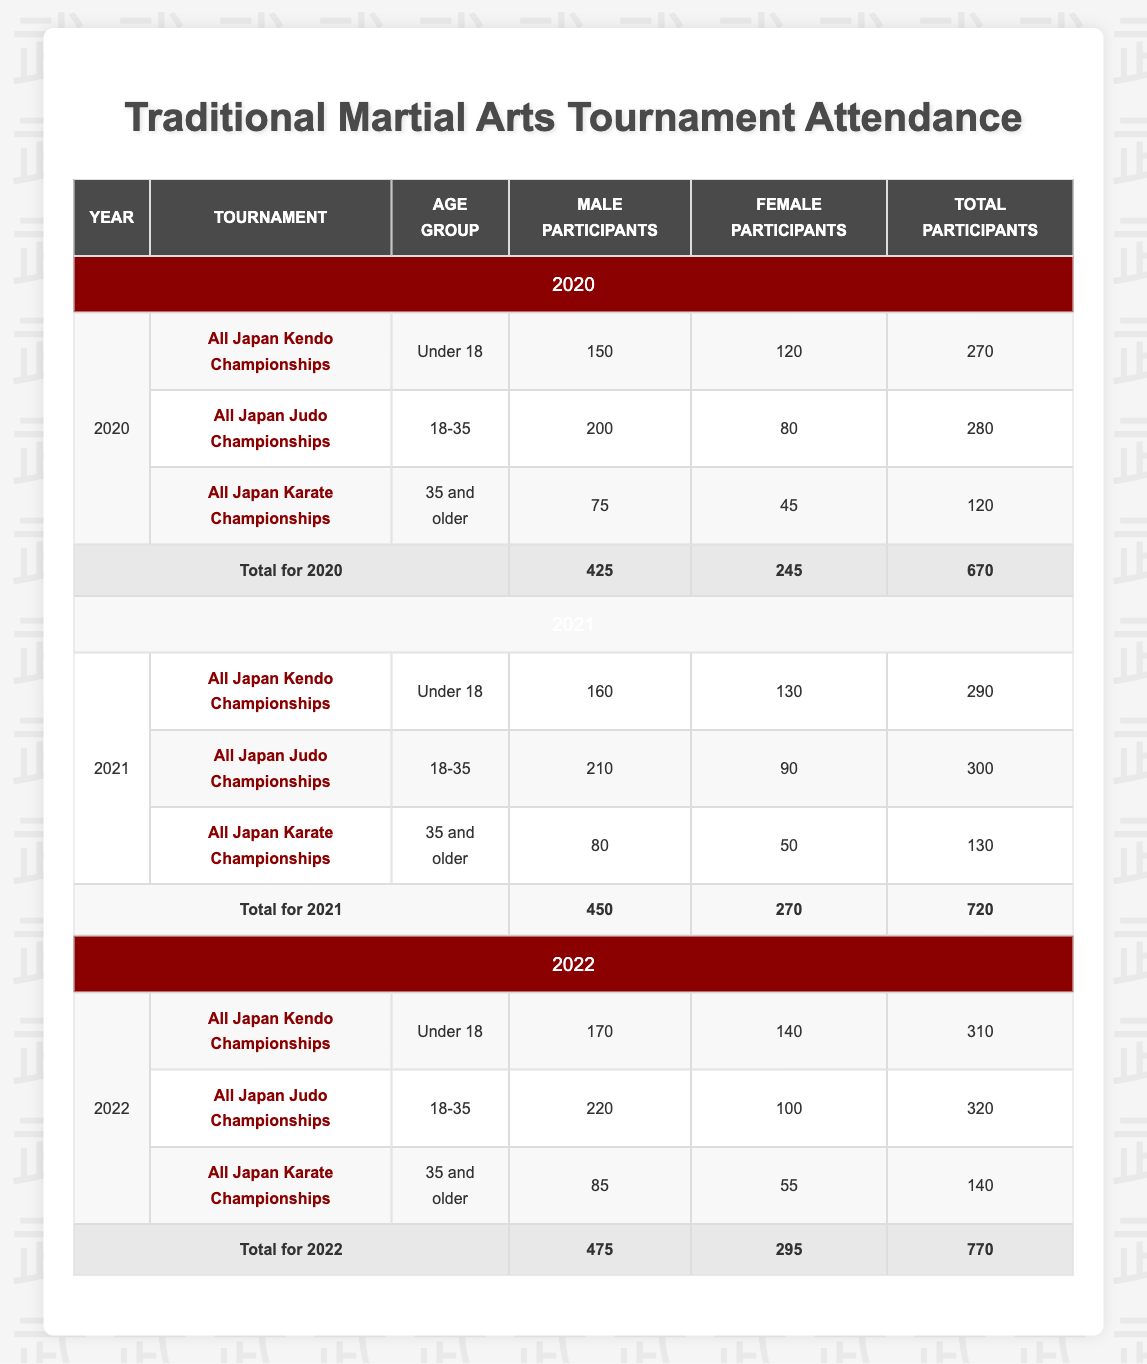What was the total number of male participants in the All Japan Judo Championships in 2021? To find the total, I look at the All Japan Judo Championships row for 2021, which shows there were 210 male participants in the age group 18-35.
Answer: 210 Which tournament had the highest number of female participants in 2022? In the year 2022, comparing the female participants across all tournaments: All Japan Kendo Championships had 140, All Japan Judo Championships had 100, and All Japan Karate Championships had 55. The highest number is 140 in the All Japan Kendo Championships.
Answer: All Japan Kendo Championships Did the total number of participants increase from 2020 to 2021? The total participants in 2020 were 670, and in 2021 it increased to 720. Since 720 is greater than 670, we can conclude that the total increased.
Answer: Yes What is the average number of male participants across all age groups in the All Japan Kendo Championships from 2020 to 2022? To calculate the average, I sum the male participants from each year: 150 (2020) + 160 (2021) + 170 (2022) = 480. There are 3 years, so the average is 480/3 = 160.
Answer: 160 Which age group had the fewest female participants in 2020? For 2020, the female participants were: Under 18 (120), age 18-35 (80), and 35 and older (45). The fewest is 45 in the age group 35 and older.
Answer: 35 and older What is the percentage increase in total participants from 2020 to 2022? Total participants in 2020: 670, and in 2022: 770. The increase is 770 - 670 = 100. To find the percentage increase, divide the increase by the original number: (100 / 670) * 100 = 14.93%, which rounds to approximately 15%.
Answer: 15% Which year had the highest number of female participants, and how many were there? I check the totals for female participants for each year: 245 in 2020, 270 in 2021, and 295 in 2022. The highest is 295 in 2022.
Answer: 2022, 295 How many total participants were there in the All Japan Karate Championships in 2021? For the All Japan Karate Championships in 2021, the total participants were 80 male and 50 female, which sums up to 130 participants.
Answer: 130 In which tournament did the Under 18 age group have the lowest number of participants across all years? I compare all Under 18 participants: 150 (2020), 160 (2021), and 170 (2022) in the Kendo Championships. There are no other tournaments for Under 18, so it is 150 in 2020.
Answer: All Japan Kendo Championships, 150 